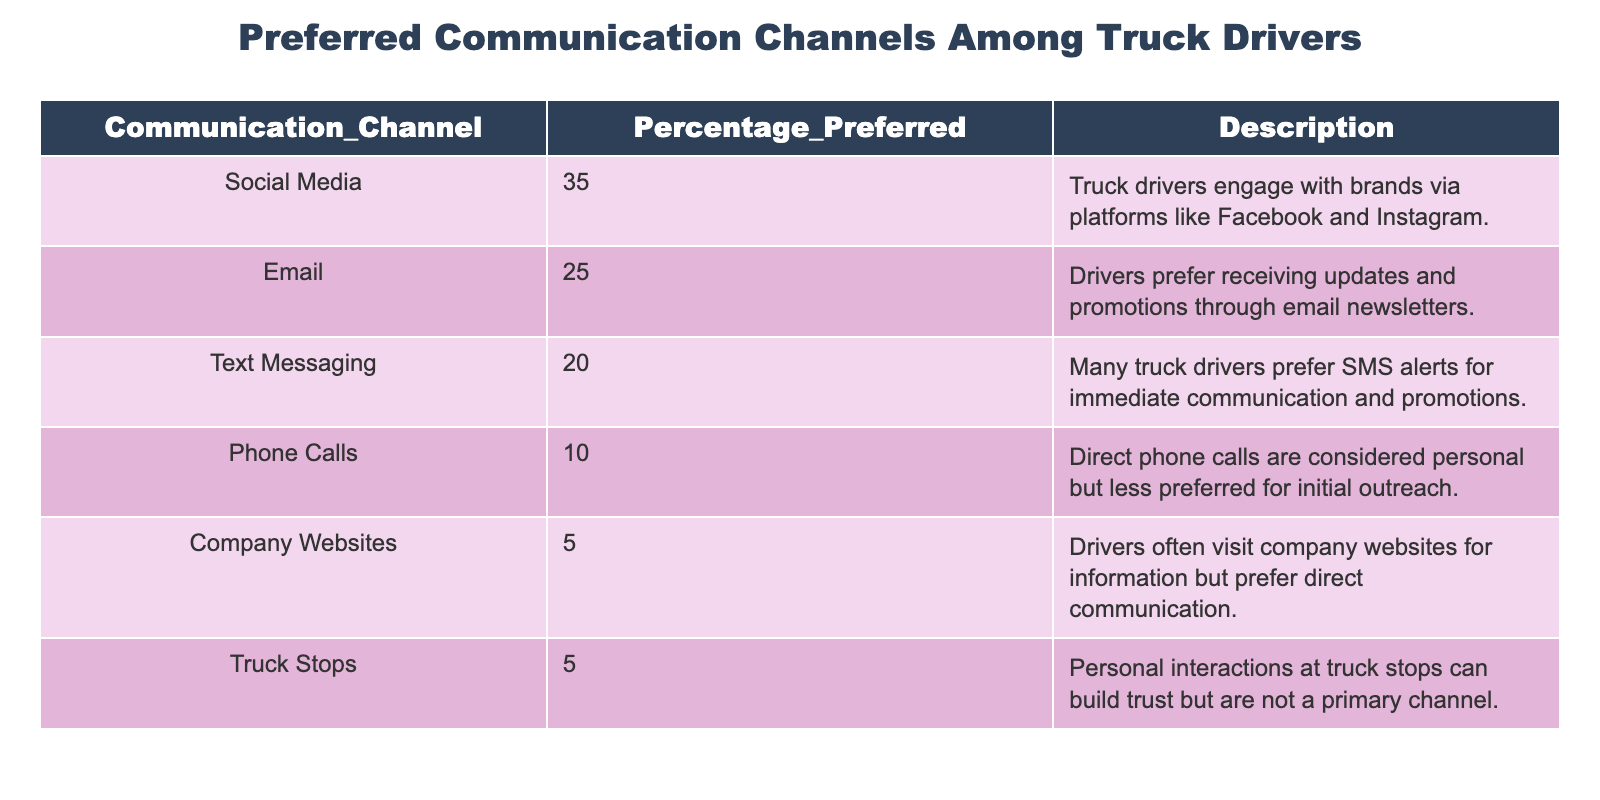What percentage of truck drivers prefer social media as a communication channel? The table shows a specific percentage associated with each communication channel. For social media, the Percentage Preferred is 35%.
Answer: 35% What is the least preferred communication channel among truck drivers? The table provides a clear comparison of the Percentage Preferred for each channel. The channels with the lowest preference at 5% are Company Websites and Truck Stops.
Answer: Company Websites and Truck Stops What is the total percentage of truck drivers who prefer email and text messaging combined? To find the total, we add the percentages for Email (25%) and Text Messaging (20%). So, 25 + 20 = 45.
Answer: 45% Is it true that phone calls are more preferred than text messaging among truck drivers? By comparing the respective percentages, Phone Calls have a preference of 10%, while Text Messaging has a preference of 20%. Therefore, the statement is false.
Answer: No What percentage of truck drivers engage through channels that are considered personal (Phone Calls and Text Messaging)? Personal channels include Phone Calls (10%) and Text Messaging (20%). Adding these gives us 10 + 20 = 30%.
Answer: 30% What is the difference in percentage preference between social media and email? From the table, Social Media has 35% preference and Email has 25%. The difference is calculated as 35 - 25 = 10%.
Answer: 10% How many more truck drivers prefer social media compared to truck stops? According to the table, Social Media has 35% while Truck Stops have 5%. The difference is 35 - 5 = 30%, indicating significantly higher preference for social media.
Answer: 30% What is the average preference for the top three communication channels? The top three channels are Social Media (35%), Email (25%), and Text Messaging (20%). To find the average, sum these values: 35 + 25 + 20 = 80, then divide by 3, giving 80 / 3 = approximately 26.67%.
Answer: Approximately 26.67% 